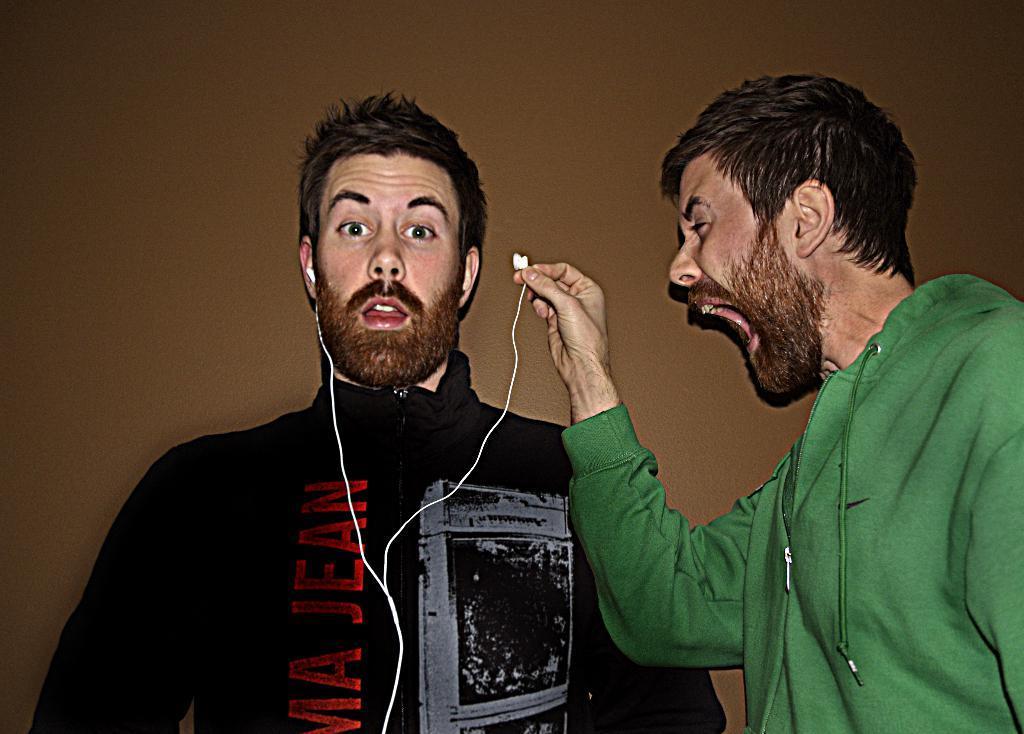Could you give a brief overview of what you see in this image? In this image there are two people, one of them is holding an earphone in his hand. 